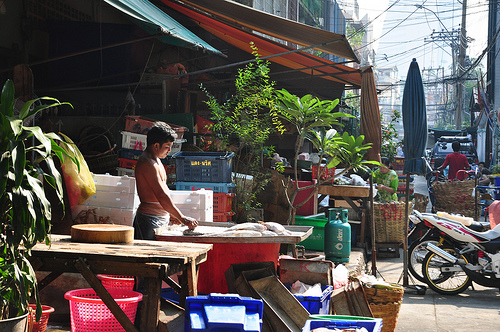<image>
Is the boy above the basket? No. The boy is not positioned above the basket. The vertical arrangement shows a different relationship. 